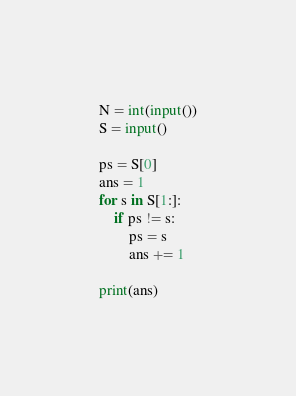<code> <loc_0><loc_0><loc_500><loc_500><_Python_>N = int(input())
S = input()

ps = S[0]
ans = 1
for s in S[1:]:
    if ps != s:
        ps = s
        ans += 1

print(ans)


</code> 